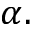Convert formula to latex. <formula><loc_0><loc_0><loc_500><loc_500>\alpha .</formula> 